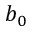<formula> <loc_0><loc_0><loc_500><loc_500>b _ { 0 }</formula> 